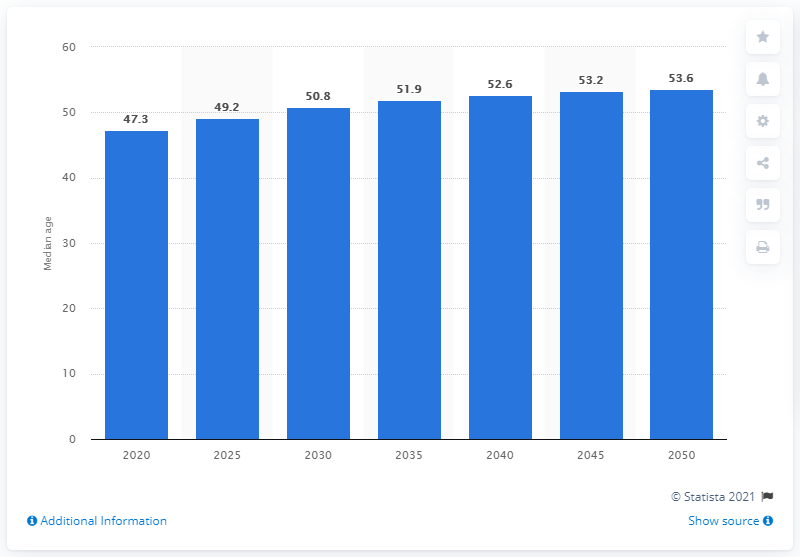Outline some significant characteristics in this image. The median age of the population in Italy is projected to increase until the year 2050. 